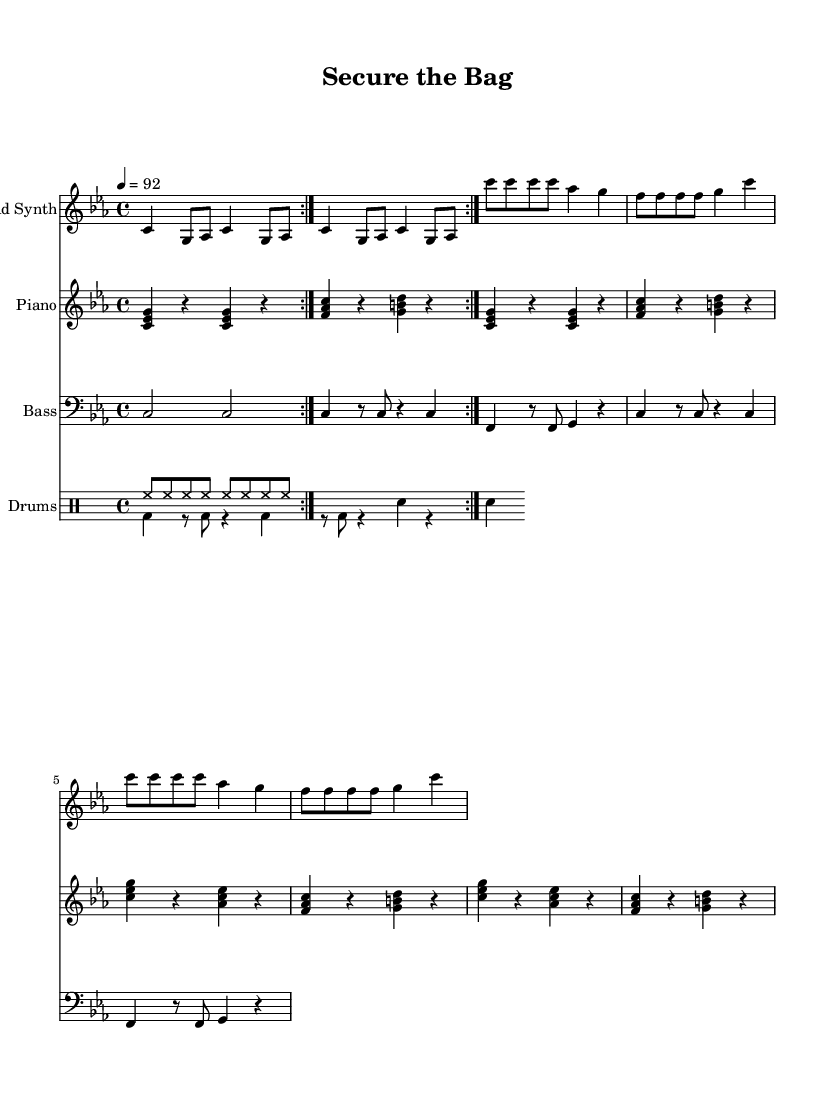What is the key signature of this music? The key signature indicates C minor, which has three flats: B flat, E flat, and A flat. This can be determined by looking at the first few measures of the sheet music where the key signature is marked.
Answer: C minor What is the time signature of this piece? The time signature is 4/4, meaning there are four beats in each measure and the quarter note gets one beat. This is shown in the first few measures of the score right after the clef and key signature.
Answer: 4/4 What is the tempo marking for this piece? The tempo marking indicates a speed of 92 beats per minute, which is found next to the tempo indication at the beginning of the score. This provides guidance on how quickly the piece should be performed.
Answer: 92 How many times is the intro repeated? The intro is indicated to be repeated two times as shown in the repeat markings at the start of the lead synth section. This means that musicians should perform that section twice before moving on.
Answer: 2 In which section does the hook appear? The hook appears after the verse sections, as indicated by the labels and progression in the sheet music structure. It consists of a melodic section followed by distinct chord patterns.
Answer: Hook What type of instruments are included in the score? The score includes lead synth, piano, bass, and drums. This can be identified by the different staff sections labeled for each instrument at the beginning of the sheet music.
Answer: Lead Synth, Piano, Bass, Drums Which rhythmic pattern is played by the drums? The drums contain a high-hat pattern followed by a bass and snare pattern, clearly labeled as 'drumPatternUp' and 'drumPatternDown' in the drumming staff, showing typical hip hop elements.
Answer: High-hat and Bass/Snare patterns 